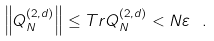<formula> <loc_0><loc_0><loc_500><loc_500>\left \| Q _ { N } ^ { \left ( 2 , d \right ) } \right \| \leq T r Q _ { N } ^ { \left ( 2 , d \right ) } < N \varepsilon \text { } .</formula> 